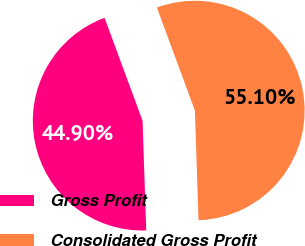Convert chart to OTSL. <chart><loc_0><loc_0><loc_500><loc_500><pie_chart><fcel>Gross Profit<fcel>Consolidated Gross Profit<nl><fcel>44.9%<fcel>55.1%<nl></chart> 